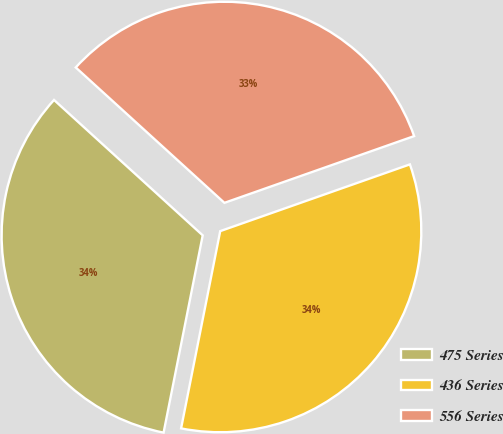Convert chart to OTSL. <chart><loc_0><loc_0><loc_500><loc_500><pie_chart><fcel>475 Series<fcel>436 Series<fcel>556 Series<nl><fcel>33.64%<fcel>33.5%<fcel>32.86%<nl></chart> 